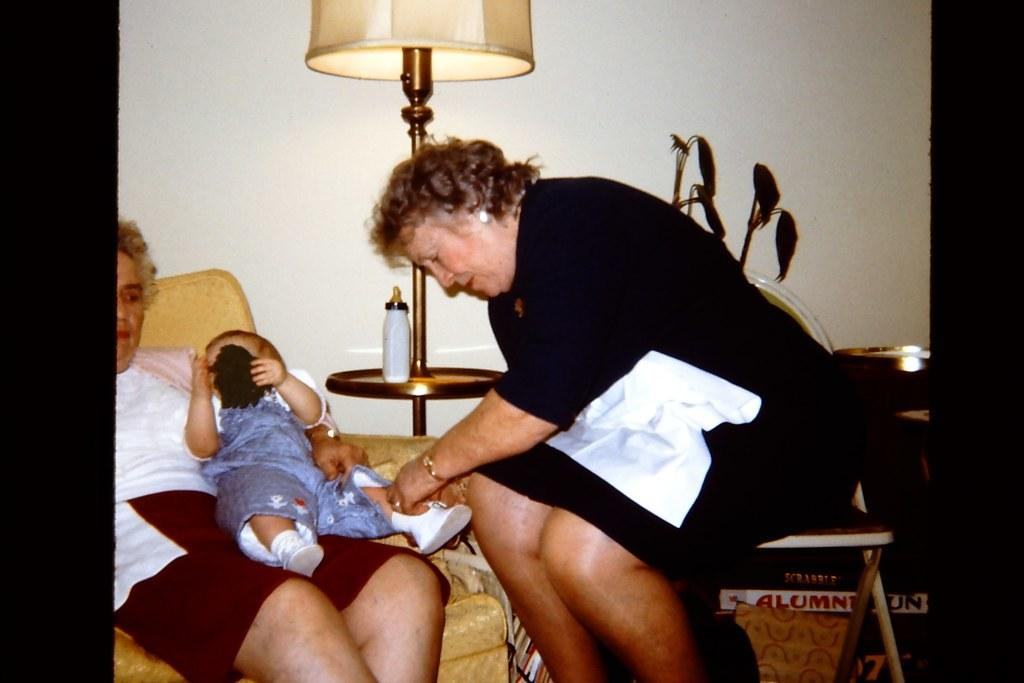How many women are in the image? There are two women in the image. What is one of the women doing with the baby? One of the women is holding a baby. What position are the women in? Both women are sitting. What objects can be seen in the background of the image? There is a lamp, a bottle, and a wall in the background of the image. What grade is the baby in the image? The baby is not in school and therefore does not have a grade. What type of patch is visible on the wall in the image? There is no patch visible on the wall in the image. 